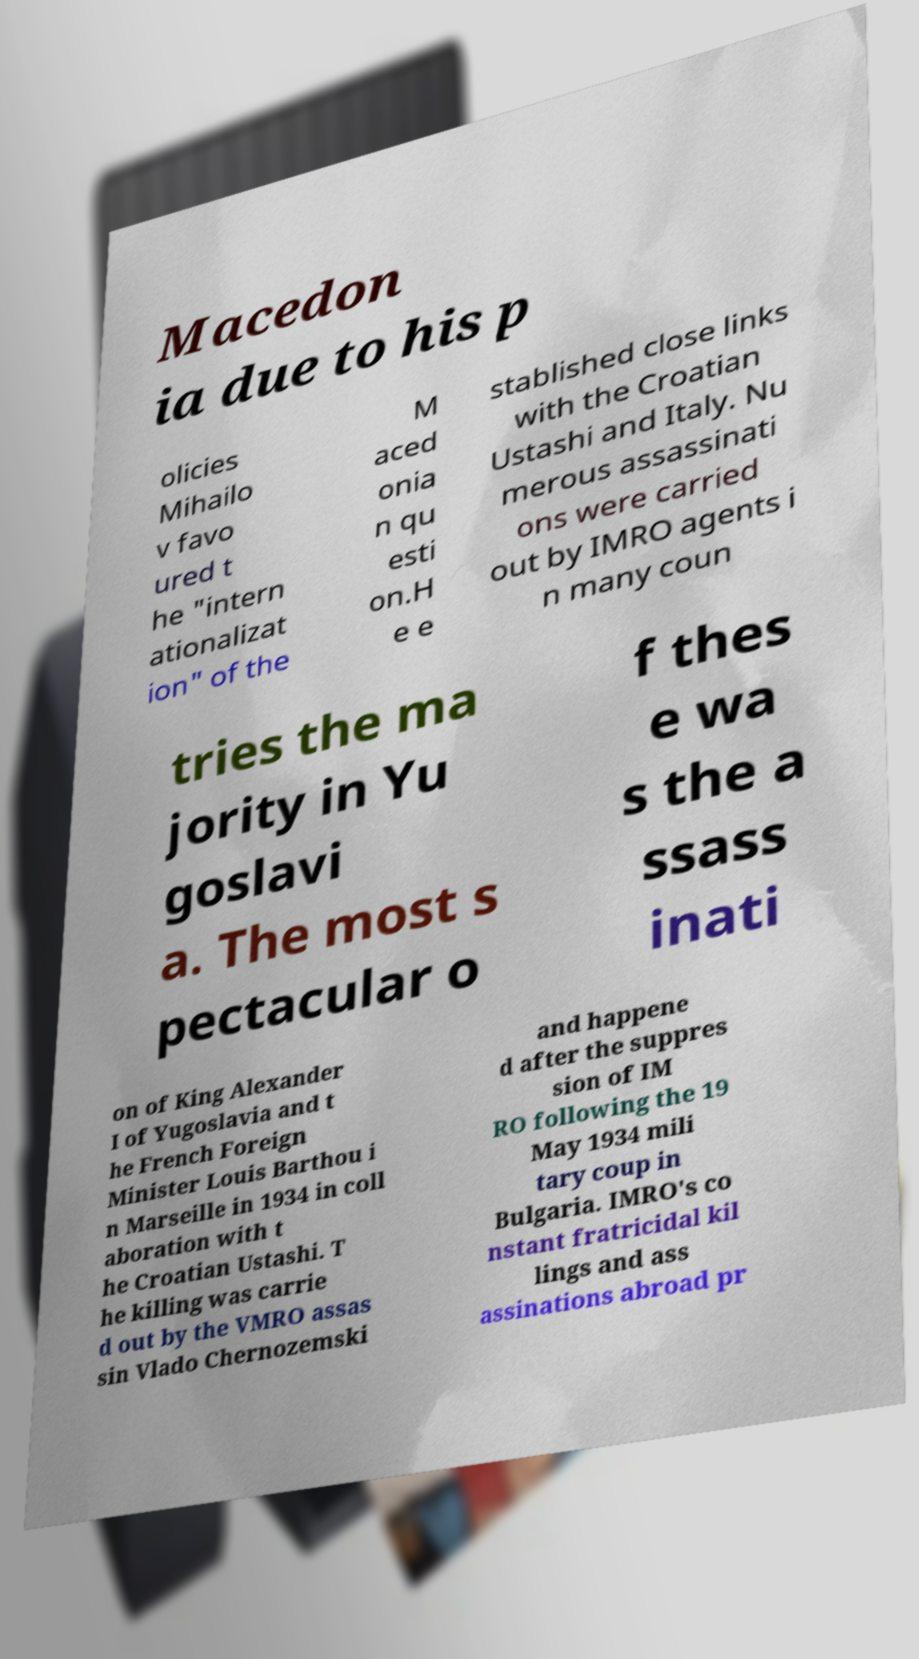Could you extract and type out the text from this image? Macedon ia due to his p olicies Mihailo v favo ured t he "intern ationalizat ion" of the M aced onia n qu esti on.H e e stablished close links with the Croatian Ustashi and Italy. Nu merous assassinati ons were carried out by IMRO agents i n many coun tries the ma jority in Yu goslavi a. The most s pectacular o f thes e wa s the a ssass inati on of King Alexander I of Yugoslavia and t he French Foreign Minister Louis Barthou i n Marseille in 1934 in coll aboration with t he Croatian Ustashi. T he killing was carrie d out by the VMRO assas sin Vlado Chernozemski and happene d after the suppres sion of IM RO following the 19 May 1934 mili tary coup in Bulgaria. IMRO's co nstant fratricidal kil lings and ass assinations abroad pr 